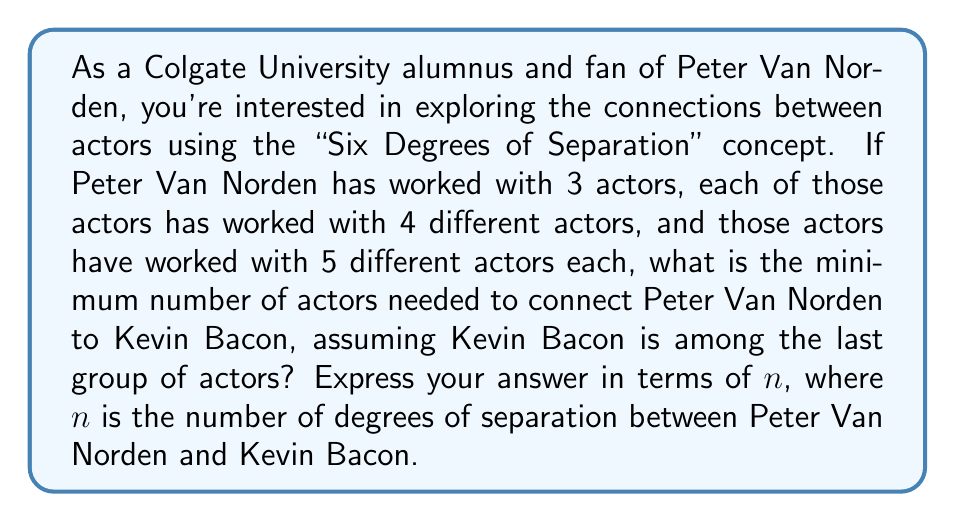Can you solve this math problem? To solve this problem, we need to consider the structure of the connections between actors:

1. Peter Van Norden is at the center of our network.
2. He has worked with 3 actors (1st degree).
3. Each of those 3 actors has worked with 4 different actors (2nd degree).
4. Each of the actors in the 2nd degree has worked with 5 different actors (3rd degree).
5. Kevin Bacon is assumed to be among the actors in the 3rd degree.

Let's calculate the number of actors at each level:

1. 1st degree: 3 actors
2. 2nd degree: $3 \times 4 = 12$ actors
3. 3rd degree: $12 \times 5 = 60$ actors

The total number of actors in this network, including Peter Van Norden, is:

$$1 + 3 + 12 + 60 = 76$$

However, the question asks for the minimum number of actors needed to connect Peter Van Norden to Kevin Bacon. We don't need all the actors in the network, just those in the shortest path:

1. Peter Van Norden
2. One actor from the 1st degree
3. One actor from the 2nd degree
4. Kevin Bacon (assumed to be in the 3rd degree)

Therefore, the minimum number of actors needed is 4, which represents 3 degrees of separation ($n = 3$).

In general, for $n$ degrees of separation, the minimum number of actors needed would be $n + 1$.
Answer: $n + 1 = 4$ actors, where $n = 3$ degrees of separation 